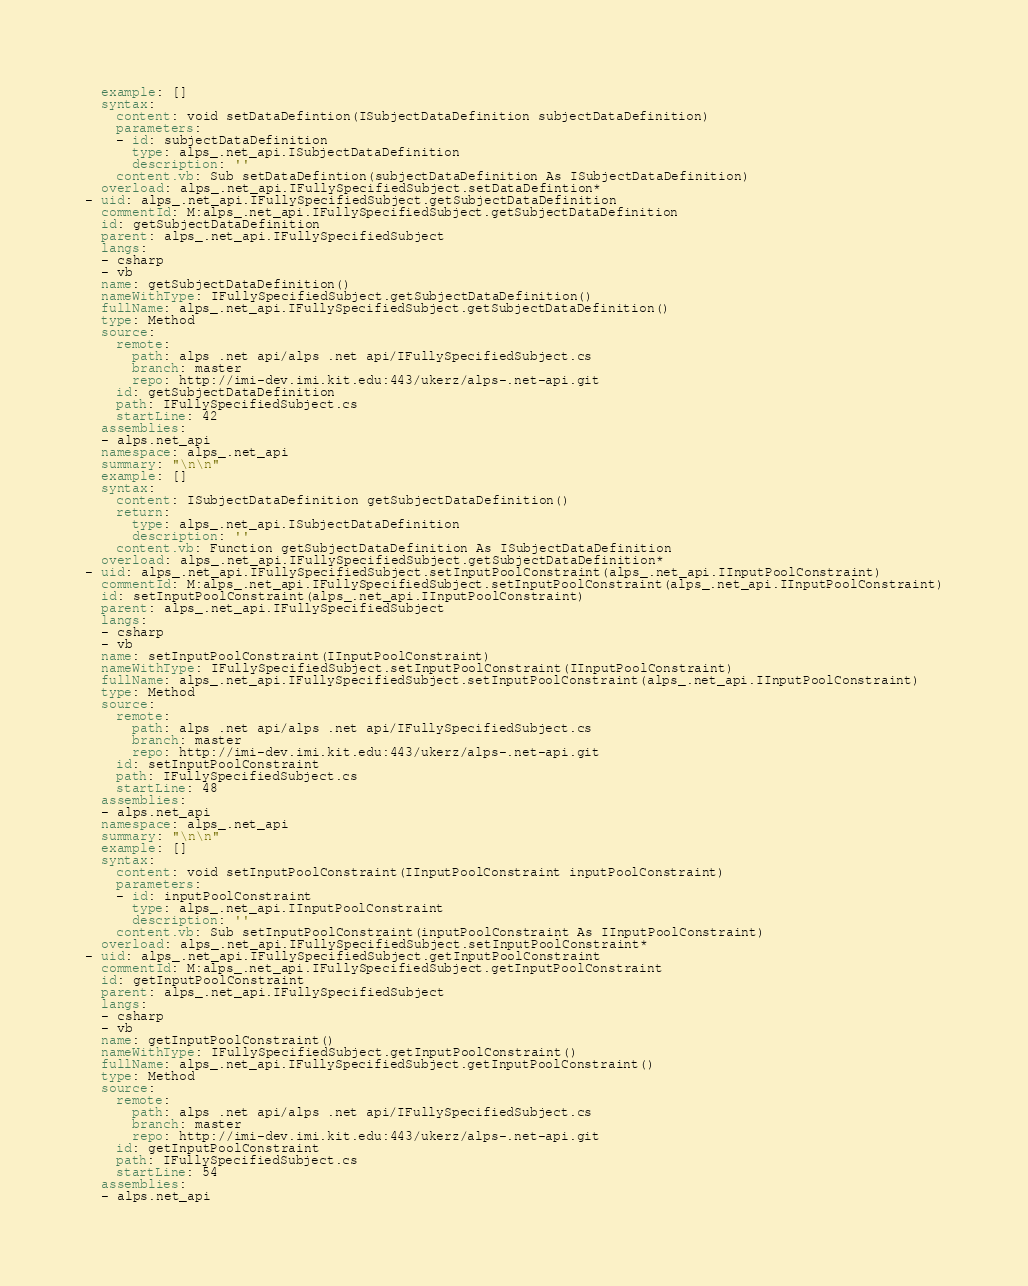<code> <loc_0><loc_0><loc_500><loc_500><_YAML_>  example: []
  syntax:
    content: void setDataDefintion(ISubjectDataDefinition subjectDataDefinition)
    parameters:
    - id: subjectDataDefinition
      type: alps_.net_api.ISubjectDataDefinition
      description: ''
    content.vb: Sub setDataDefintion(subjectDataDefinition As ISubjectDataDefinition)
  overload: alps_.net_api.IFullySpecifiedSubject.setDataDefintion*
- uid: alps_.net_api.IFullySpecifiedSubject.getSubjectDataDefinition
  commentId: M:alps_.net_api.IFullySpecifiedSubject.getSubjectDataDefinition
  id: getSubjectDataDefinition
  parent: alps_.net_api.IFullySpecifiedSubject
  langs:
  - csharp
  - vb
  name: getSubjectDataDefinition()
  nameWithType: IFullySpecifiedSubject.getSubjectDataDefinition()
  fullName: alps_.net_api.IFullySpecifiedSubject.getSubjectDataDefinition()
  type: Method
  source:
    remote:
      path: alps .net api/alps .net api/IFullySpecifiedSubject.cs
      branch: master
      repo: http://imi-dev.imi.kit.edu:443/ukerz/alps-.net-api.git
    id: getSubjectDataDefinition
    path: IFullySpecifiedSubject.cs
    startLine: 42
  assemblies:
  - alps.net_api
  namespace: alps_.net_api
  summary: "\n\n"
  example: []
  syntax:
    content: ISubjectDataDefinition getSubjectDataDefinition()
    return:
      type: alps_.net_api.ISubjectDataDefinition
      description: ''
    content.vb: Function getSubjectDataDefinition As ISubjectDataDefinition
  overload: alps_.net_api.IFullySpecifiedSubject.getSubjectDataDefinition*
- uid: alps_.net_api.IFullySpecifiedSubject.setInputPoolConstraint(alps_.net_api.IInputPoolConstraint)
  commentId: M:alps_.net_api.IFullySpecifiedSubject.setInputPoolConstraint(alps_.net_api.IInputPoolConstraint)
  id: setInputPoolConstraint(alps_.net_api.IInputPoolConstraint)
  parent: alps_.net_api.IFullySpecifiedSubject
  langs:
  - csharp
  - vb
  name: setInputPoolConstraint(IInputPoolConstraint)
  nameWithType: IFullySpecifiedSubject.setInputPoolConstraint(IInputPoolConstraint)
  fullName: alps_.net_api.IFullySpecifiedSubject.setInputPoolConstraint(alps_.net_api.IInputPoolConstraint)
  type: Method
  source:
    remote:
      path: alps .net api/alps .net api/IFullySpecifiedSubject.cs
      branch: master
      repo: http://imi-dev.imi.kit.edu:443/ukerz/alps-.net-api.git
    id: setInputPoolConstraint
    path: IFullySpecifiedSubject.cs
    startLine: 48
  assemblies:
  - alps.net_api
  namespace: alps_.net_api
  summary: "\n\n"
  example: []
  syntax:
    content: void setInputPoolConstraint(IInputPoolConstraint inputPoolConstraint)
    parameters:
    - id: inputPoolConstraint
      type: alps_.net_api.IInputPoolConstraint
      description: ''
    content.vb: Sub setInputPoolConstraint(inputPoolConstraint As IInputPoolConstraint)
  overload: alps_.net_api.IFullySpecifiedSubject.setInputPoolConstraint*
- uid: alps_.net_api.IFullySpecifiedSubject.getInputPoolConstraint
  commentId: M:alps_.net_api.IFullySpecifiedSubject.getInputPoolConstraint
  id: getInputPoolConstraint
  parent: alps_.net_api.IFullySpecifiedSubject
  langs:
  - csharp
  - vb
  name: getInputPoolConstraint()
  nameWithType: IFullySpecifiedSubject.getInputPoolConstraint()
  fullName: alps_.net_api.IFullySpecifiedSubject.getInputPoolConstraint()
  type: Method
  source:
    remote:
      path: alps .net api/alps .net api/IFullySpecifiedSubject.cs
      branch: master
      repo: http://imi-dev.imi.kit.edu:443/ukerz/alps-.net-api.git
    id: getInputPoolConstraint
    path: IFullySpecifiedSubject.cs
    startLine: 54
  assemblies:
  - alps.net_api</code> 